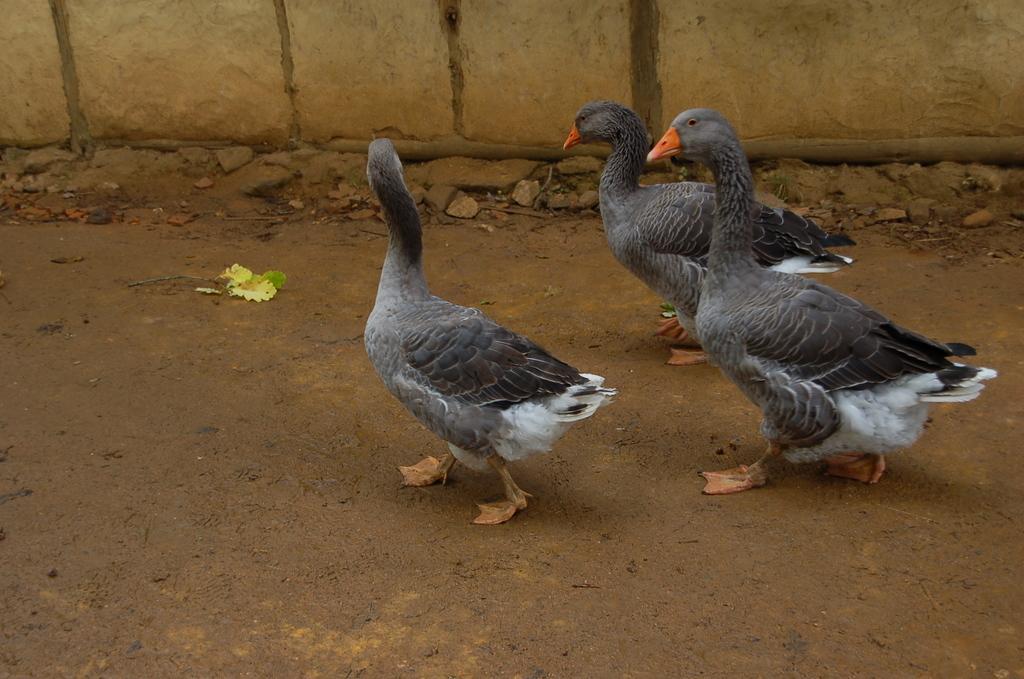How would you summarize this image in a sentence or two? In this picture we can observe three ducks walking on the road. They are in grey and white color with an orange peaks. In the background there is a wall which is in yellow color. 